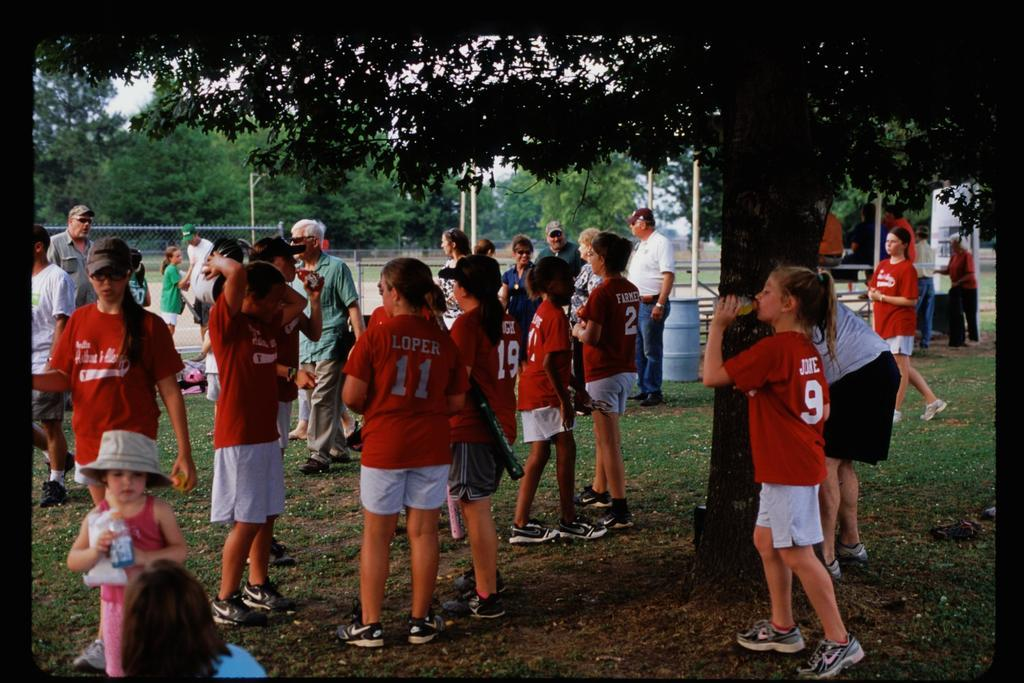How many people are in the image? There are people in the image, but the exact number is not specified. What type of material is present in the image? There is mesh in the image. What structures can be seen in the image? There are poles in the image. What type of natural environment is visible in the image? There are trees and grass in the image. What else can be seen in the image besides people and natural elements? There are objects in the image. What are some people doing with the objects in the image? Some people are holding objects in the image. How does the anger of the people in the image affect the temperature of the grass? There is no mention of anger or temperature in the image, so it is not possible to answer this question. 